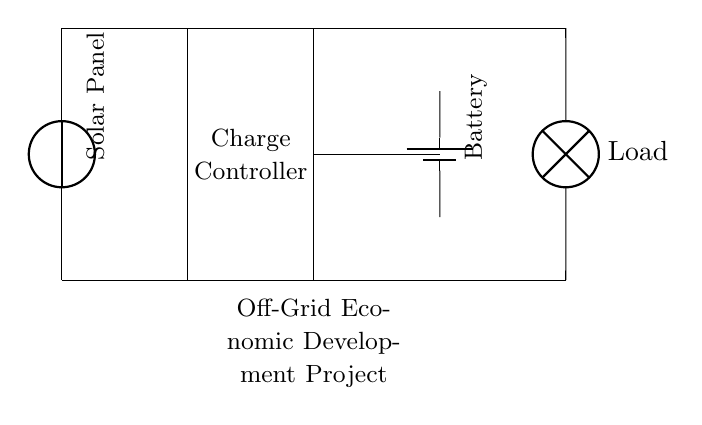What is the primary renewable energy source in this circuit? The circuit diagram includes a solar panel, which serves as the primary renewable energy source, converting sunlight into electrical energy.
Answer: Solar Panel What component regulates the voltage before charging the battery? The circuit contains a charge controller, which is crucial in managing the voltage and current from the solar panel to prevent overcharging the battery.
Answer: Charge Controller What is connected to the battery in this circuit? The battery is connected to a load, which consumes the stored energy. The connection between the battery and the load facilitates energy delivery from storage to usage.
Answer: Load How many main components are visible in this charging circuit? By observing the diagram, we can identify a total of four main components: the solar panel, charge controller, battery, and load.
Answer: Four What is the purpose of the charge controller in this circuit? The charge controller's primary role is to regulate the current and voltage from the solar panel to ensure the battery is charged safely without damage, thus protecting both the battery and the solar panel from potential faults.
Answer: To regulate charging At what height does the solar panel sit in relation to the charge controller? The solar panel is positioned above the charge controller in the diagram, indicating its layout and illustrating the flow of energy from the panel downwards to the controller, then to the battery.
Answer: Above 